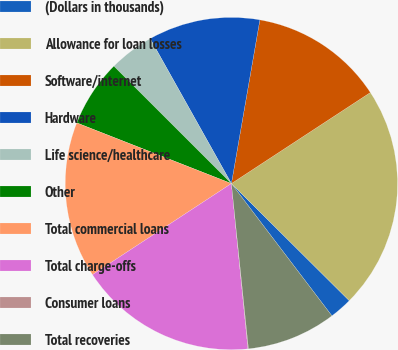Convert chart. <chart><loc_0><loc_0><loc_500><loc_500><pie_chart><fcel>(Dollars in thousands)<fcel>Allowance for loan losses<fcel>Software/internet<fcel>Hardware<fcel>Life science/healthcare<fcel>Other<fcel>Total commercial loans<fcel>Total charge-offs<fcel>Consumer loans<fcel>Total recoveries<nl><fcel>2.21%<fcel>21.68%<fcel>13.03%<fcel>10.87%<fcel>4.38%<fcel>6.54%<fcel>15.19%<fcel>17.35%<fcel>0.05%<fcel>8.7%<nl></chart> 